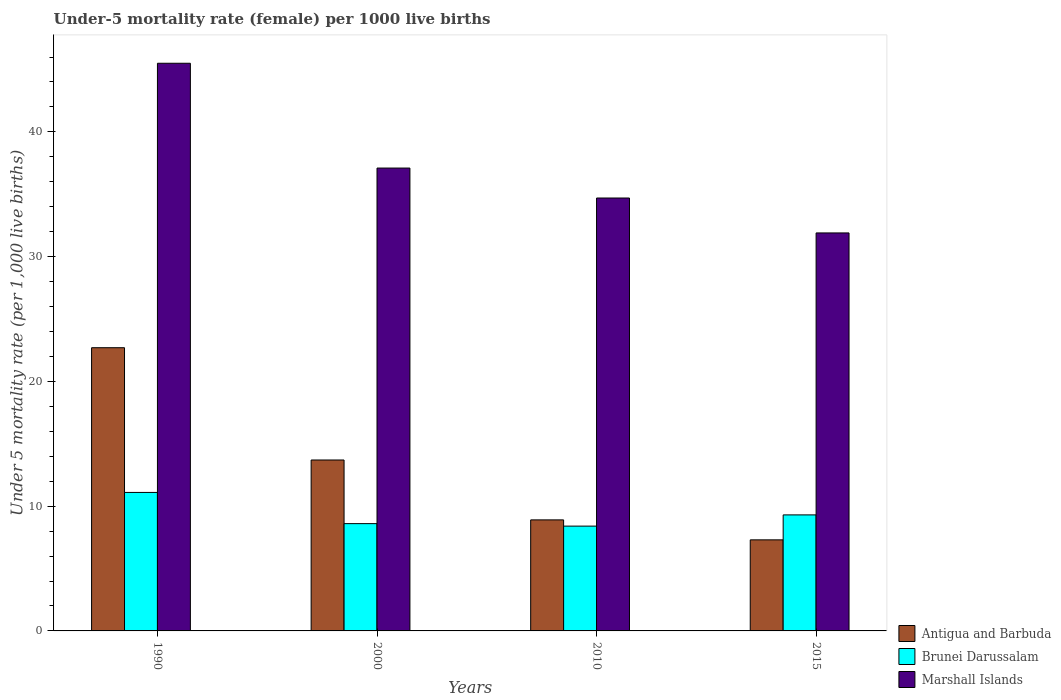How many different coloured bars are there?
Your answer should be very brief. 3. Are the number of bars per tick equal to the number of legend labels?
Ensure brevity in your answer.  Yes. How many bars are there on the 2nd tick from the right?
Provide a short and direct response. 3. What is the label of the 4th group of bars from the left?
Make the answer very short. 2015. What is the under-five mortality rate in Antigua and Barbuda in 1990?
Offer a very short reply. 22.7. Across all years, what is the maximum under-five mortality rate in Antigua and Barbuda?
Give a very brief answer. 22.7. Across all years, what is the minimum under-five mortality rate in Marshall Islands?
Provide a short and direct response. 31.9. In which year was the under-five mortality rate in Marshall Islands minimum?
Provide a short and direct response. 2015. What is the total under-five mortality rate in Marshall Islands in the graph?
Offer a terse response. 149.2. What is the difference between the under-five mortality rate in Brunei Darussalam in 2000 and that in 2010?
Make the answer very short. 0.2. What is the difference between the under-five mortality rate in Antigua and Barbuda in 2000 and the under-five mortality rate in Marshall Islands in 2010?
Provide a succinct answer. -21. What is the average under-five mortality rate in Antigua and Barbuda per year?
Provide a succinct answer. 13.15. What is the ratio of the under-five mortality rate in Antigua and Barbuda in 1990 to that in 2015?
Ensure brevity in your answer.  3.11. Is the under-five mortality rate in Brunei Darussalam in 1990 less than that in 2015?
Offer a very short reply. No. Is the difference between the under-five mortality rate in Brunei Darussalam in 1990 and 2010 greater than the difference between the under-five mortality rate in Antigua and Barbuda in 1990 and 2010?
Ensure brevity in your answer.  No. What is the difference between the highest and the second highest under-five mortality rate in Marshall Islands?
Provide a succinct answer. 8.4. What is the difference between the highest and the lowest under-five mortality rate in Brunei Darussalam?
Your answer should be very brief. 2.7. In how many years, is the under-five mortality rate in Brunei Darussalam greater than the average under-five mortality rate in Brunei Darussalam taken over all years?
Offer a very short reply. 1. Is the sum of the under-five mortality rate in Antigua and Barbuda in 1990 and 2015 greater than the maximum under-five mortality rate in Brunei Darussalam across all years?
Provide a succinct answer. Yes. What does the 1st bar from the left in 2000 represents?
Keep it short and to the point. Antigua and Barbuda. What does the 1st bar from the right in 2015 represents?
Keep it short and to the point. Marshall Islands. What is the difference between two consecutive major ticks on the Y-axis?
Offer a terse response. 10. Does the graph contain grids?
Offer a very short reply. No. Where does the legend appear in the graph?
Offer a very short reply. Bottom right. What is the title of the graph?
Your answer should be very brief. Under-5 mortality rate (female) per 1000 live births. Does "Latin America(developing only)" appear as one of the legend labels in the graph?
Ensure brevity in your answer.  No. What is the label or title of the Y-axis?
Make the answer very short. Under 5 mortality rate (per 1,0 live births). What is the Under 5 mortality rate (per 1,000 live births) of Antigua and Barbuda in 1990?
Give a very brief answer. 22.7. What is the Under 5 mortality rate (per 1,000 live births) in Brunei Darussalam in 1990?
Make the answer very short. 11.1. What is the Under 5 mortality rate (per 1,000 live births) in Marshall Islands in 1990?
Make the answer very short. 45.5. What is the Under 5 mortality rate (per 1,000 live births) of Antigua and Barbuda in 2000?
Give a very brief answer. 13.7. What is the Under 5 mortality rate (per 1,000 live births) of Brunei Darussalam in 2000?
Offer a terse response. 8.6. What is the Under 5 mortality rate (per 1,000 live births) of Marshall Islands in 2000?
Offer a terse response. 37.1. What is the Under 5 mortality rate (per 1,000 live births) of Antigua and Barbuda in 2010?
Keep it short and to the point. 8.9. What is the Under 5 mortality rate (per 1,000 live births) in Marshall Islands in 2010?
Keep it short and to the point. 34.7. What is the Under 5 mortality rate (per 1,000 live births) of Antigua and Barbuda in 2015?
Your answer should be very brief. 7.3. What is the Under 5 mortality rate (per 1,000 live births) of Marshall Islands in 2015?
Offer a terse response. 31.9. Across all years, what is the maximum Under 5 mortality rate (per 1,000 live births) in Antigua and Barbuda?
Ensure brevity in your answer.  22.7. Across all years, what is the maximum Under 5 mortality rate (per 1,000 live births) of Marshall Islands?
Keep it short and to the point. 45.5. Across all years, what is the minimum Under 5 mortality rate (per 1,000 live births) of Antigua and Barbuda?
Your answer should be very brief. 7.3. Across all years, what is the minimum Under 5 mortality rate (per 1,000 live births) in Marshall Islands?
Your answer should be very brief. 31.9. What is the total Under 5 mortality rate (per 1,000 live births) of Antigua and Barbuda in the graph?
Your answer should be very brief. 52.6. What is the total Under 5 mortality rate (per 1,000 live births) of Brunei Darussalam in the graph?
Your answer should be very brief. 37.4. What is the total Under 5 mortality rate (per 1,000 live births) in Marshall Islands in the graph?
Provide a succinct answer. 149.2. What is the difference between the Under 5 mortality rate (per 1,000 live births) of Brunei Darussalam in 1990 and that in 2000?
Keep it short and to the point. 2.5. What is the difference between the Under 5 mortality rate (per 1,000 live births) in Antigua and Barbuda in 1990 and that in 2010?
Your answer should be compact. 13.8. What is the difference between the Under 5 mortality rate (per 1,000 live births) of Brunei Darussalam in 1990 and that in 2010?
Keep it short and to the point. 2.7. What is the difference between the Under 5 mortality rate (per 1,000 live births) of Marshall Islands in 1990 and that in 2015?
Keep it short and to the point. 13.6. What is the difference between the Under 5 mortality rate (per 1,000 live births) of Brunei Darussalam in 2000 and that in 2015?
Give a very brief answer. -0.7. What is the difference between the Under 5 mortality rate (per 1,000 live births) in Antigua and Barbuda in 2010 and that in 2015?
Keep it short and to the point. 1.6. What is the difference between the Under 5 mortality rate (per 1,000 live births) of Brunei Darussalam in 2010 and that in 2015?
Your answer should be compact. -0.9. What is the difference between the Under 5 mortality rate (per 1,000 live births) of Marshall Islands in 2010 and that in 2015?
Ensure brevity in your answer.  2.8. What is the difference between the Under 5 mortality rate (per 1,000 live births) of Antigua and Barbuda in 1990 and the Under 5 mortality rate (per 1,000 live births) of Brunei Darussalam in 2000?
Provide a succinct answer. 14.1. What is the difference between the Under 5 mortality rate (per 1,000 live births) in Antigua and Barbuda in 1990 and the Under 5 mortality rate (per 1,000 live births) in Marshall Islands in 2000?
Provide a succinct answer. -14.4. What is the difference between the Under 5 mortality rate (per 1,000 live births) in Brunei Darussalam in 1990 and the Under 5 mortality rate (per 1,000 live births) in Marshall Islands in 2000?
Your response must be concise. -26. What is the difference between the Under 5 mortality rate (per 1,000 live births) in Antigua and Barbuda in 1990 and the Under 5 mortality rate (per 1,000 live births) in Brunei Darussalam in 2010?
Your answer should be very brief. 14.3. What is the difference between the Under 5 mortality rate (per 1,000 live births) in Antigua and Barbuda in 1990 and the Under 5 mortality rate (per 1,000 live births) in Marshall Islands in 2010?
Provide a succinct answer. -12. What is the difference between the Under 5 mortality rate (per 1,000 live births) in Brunei Darussalam in 1990 and the Under 5 mortality rate (per 1,000 live births) in Marshall Islands in 2010?
Your answer should be very brief. -23.6. What is the difference between the Under 5 mortality rate (per 1,000 live births) of Antigua and Barbuda in 1990 and the Under 5 mortality rate (per 1,000 live births) of Marshall Islands in 2015?
Offer a very short reply. -9.2. What is the difference between the Under 5 mortality rate (per 1,000 live births) in Brunei Darussalam in 1990 and the Under 5 mortality rate (per 1,000 live births) in Marshall Islands in 2015?
Provide a short and direct response. -20.8. What is the difference between the Under 5 mortality rate (per 1,000 live births) in Antigua and Barbuda in 2000 and the Under 5 mortality rate (per 1,000 live births) in Brunei Darussalam in 2010?
Keep it short and to the point. 5.3. What is the difference between the Under 5 mortality rate (per 1,000 live births) in Brunei Darussalam in 2000 and the Under 5 mortality rate (per 1,000 live births) in Marshall Islands in 2010?
Give a very brief answer. -26.1. What is the difference between the Under 5 mortality rate (per 1,000 live births) of Antigua and Barbuda in 2000 and the Under 5 mortality rate (per 1,000 live births) of Brunei Darussalam in 2015?
Make the answer very short. 4.4. What is the difference between the Under 5 mortality rate (per 1,000 live births) in Antigua and Barbuda in 2000 and the Under 5 mortality rate (per 1,000 live births) in Marshall Islands in 2015?
Provide a short and direct response. -18.2. What is the difference between the Under 5 mortality rate (per 1,000 live births) in Brunei Darussalam in 2000 and the Under 5 mortality rate (per 1,000 live births) in Marshall Islands in 2015?
Your answer should be very brief. -23.3. What is the difference between the Under 5 mortality rate (per 1,000 live births) in Antigua and Barbuda in 2010 and the Under 5 mortality rate (per 1,000 live births) in Marshall Islands in 2015?
Your answer should be very brief. -23. What is the difference between the Under 5 mortality rate (per 1,000 live births) in Brunei Darussalam in 2010 and the Under 5 mortality rate (per 1,000 live births) in Marshall Islands in 2015?
Your answer should be very brief. -23.5. What is the average Under 5 mortality rate (per 1,000 live births) of Antigua and Barbuda per year?
Offer a very short reply. 13.15. What is the average Under 5 mortality rate (per 1,000 live births) of Brunei Darussalam per year?
Your answer should be very brief. 9.35. What is the average Under 5 mortality rate (per 1,000 live births) in Marshall Islands per year?
Provide a short and direct response. 37.3. In the year 1990, what is the difference between the Under 5 mortality rate (per 1,000 live births) in Antigua and Barbuda and Under 5 mortality rate (per 1,000 live births) in Brunei Darussalam?
Provide a short and direct response. 11.6. In the year 1990, what is the difference between the Under 5 mortality rate (per 1,000 live births) in Antigua and Barbuda and Under 5 mortality rate (per 1,000 live births) in Marshall Islands?
Provide a succinct answer. -22.8. In the year 1990, what is the difference between the Under 5 mortality rate (per 1,000 live births) in Brunei Darussalam and Under 5 mortality rate (per 1,000 live births) in Marshall Islands?
Your response must be concise. -34.4. In the year 2000, what is the difference between the Under 5 mortality rate (per 1,000 live births) of Antigua and Barbuda and Under 5 mortality rate (per 1,000 live births) of Brunei Darussalam?
Your answer should be compact. 5.1. In the year 2000, what is the difference between the Under 5 mortality rate (per 1,000 live births) in Antigua and Barbuda and Under 5 mortality rate (per 1,000 live births) in Marshall Islands?
Offer a very short reply. -23.4. In the year 2000, what is the difference between the Under 5 mortality rate (per 1,000 live births) in Brunei Darussalam and Under 5 mortality rate (per 1,000 live births) in Marshall Islands?
Keep it short and to the point. -28.5. In the year 2010, what is the difference between the Under 5 mortality rate (per 1,000 live births) in Antigua and Barbuda and Under 5 mortality rate (per 1,000 live births) in Brunei Darussalam?
Offer a terse response. 0.5. In the year 2010, what is the difference between the Under 5 mortality rate (per 1,000 live births) of Antigua and Barbuda and Under 5 mortality rate (per 1,000 live births) of Marshall Islands?
Your answer should be compact. -25.8. In the year 2010, what is the difference between the Under 5 mortality rate (per 1,000 live births) in Brunei Darussalam and Under 5 mortality rate (per 1,000 live births) in Marshall Islands?
Provide a short and direct response. -26.3. In the year 2015, what is the difference between the Under 5 mortality rate (per 1,000 live births) of Antigua and Barbuda and Under 5 mortality rate (per 1,000 live births) of Brunei Darussalam?
Provide a succinct answer. -2. In the year 2015, what is the difference between the Under 5 mortality rate (per 1,000 live births) in Antigua and Barbuda and Under 5 mortality rate (per 1,000 live births) in Marshall Islands?
Ensure brevity in your answer.  -24.6. In the year 2015, what is the difference between the Under 5 mortality rate (per 1,000 live births) of Brunei Darussalam and Under 5 mortality rate (per 1,000 live births) of Marshall Islands?
Keep it short and to the point. -22.6. What is the ratio of the Under 5 mortality rate (per 1,000 live births) of Antigua and Barbuda in 1990 to that in 2000?
Ensure brevity in your answer.  1.66. What is the ratio of the Under 5 mortality rate (per 1,000 live births) in Brunei Darussalam in 1990 to that in 2000?
Ensure brevity in your answer.  1.29. What is the ratio of the Under 5 mortality rate (per 1,000 live births) in Marshall Islands in 1990 to that in 2000?
Your answer should be compact. 1.23. What is the ratio of the Under 5 mortality rate (per 1,000 live births) of Antigua and Barbuda in 1990 to that in 2010?
Offer a very short reply. 2.55. What is the ratio of the Under 5 mortality rate (per 1,000 live births) in Brunei Darussalam in 1990 to that in 2010?
Give a very brief answer. 1.32. What is the ratio of the Under 5 mortality rate (per 1,000 live births) of Marshall Islands in 1990 to that in 2010?
Your response must be concise. 1.31. What is the ratio of the Under 5 mortality rate (per 1,000 live births) of Antigua and Barbuda in 1990 to that in 2015?
Make the answer very short. 3.11. What is the ratio of the Under 5 mortality rate (per 1,000 live births) in Brunei Darussalam in 1990 to that in 2015?
Your response must be concise. 1.19. What is the ratio of the Under 5 mortality rate (per 1,000 live births) in Marshall Islands in 1990 to that in 2015?
Your response must be concise. 1.43. What is the ratio of the Under 5 mortality rate (per 1,000 live births) of Antigua and Barbuda in 2000 to that in 2010?
Your response must be concise. 1.54. What is the ratio of the Under 5 mortality rate (per 1,000 live births) of Brunei Darussalam in 2000 to that in 2010?
Provide a succinct answer. 1.02. What is the ratio of the Under 5 mortality rate (per 1,000 live births) of Marshall Islands in 2000 to that in 2010?
Offer a very short reply. 1.07. What is the ratio of the Under 5 mortality rate (per 1,000 live births) in Antigua and Barbuda in 2000 to that in 2015?
Offer a very short reply. 1.88. What is the ratio of the Under 5 mortality rate (per 1,000 live births) in Brunei Darussalam in 2000 to that in 2015?
Keep it short and to the point. 0.92. What is the ratio of the Under 5 mortality rate (per 1,000 live births) in Marshall Islands in 2000 to that in 2015?
Ensure brevity in your answer.  1.16. What is the ratio of the Under 5 mortality rate (per 1,000 live births) of Antigua and Barbuda in 2010 to that in 2015?
Give a very brief answer. 1.22. What is the ratio of the Under 5 mortality rate (per 1,000 live births) of Brunei Darussalam in 2010 to that in 2015?
Ensure brevity in your answer.  0.9. What is the ratio of the Under 5 mortality rate (per 1,000 live births) of Marshall Islands in 2010 to that in 2015?
Ensure brevity in your answer.  1.09. What is the difference between the highest and the second highest Under 5 mortality rate (per 1,000 live births) in Brunei Darussalam?
Give a very brief answer. 1.8. What is the difference between the highest and the lowest Under 5 mortality rate (per 1,000 live births) of Brunei Darussalam?
Offer a very short reply. 2.7. What is the difference between the highest and the lowest Under 5 mortality rate (per 1,000 live births) of Marshall Islands?
Give a very brief answer. 13.6. 